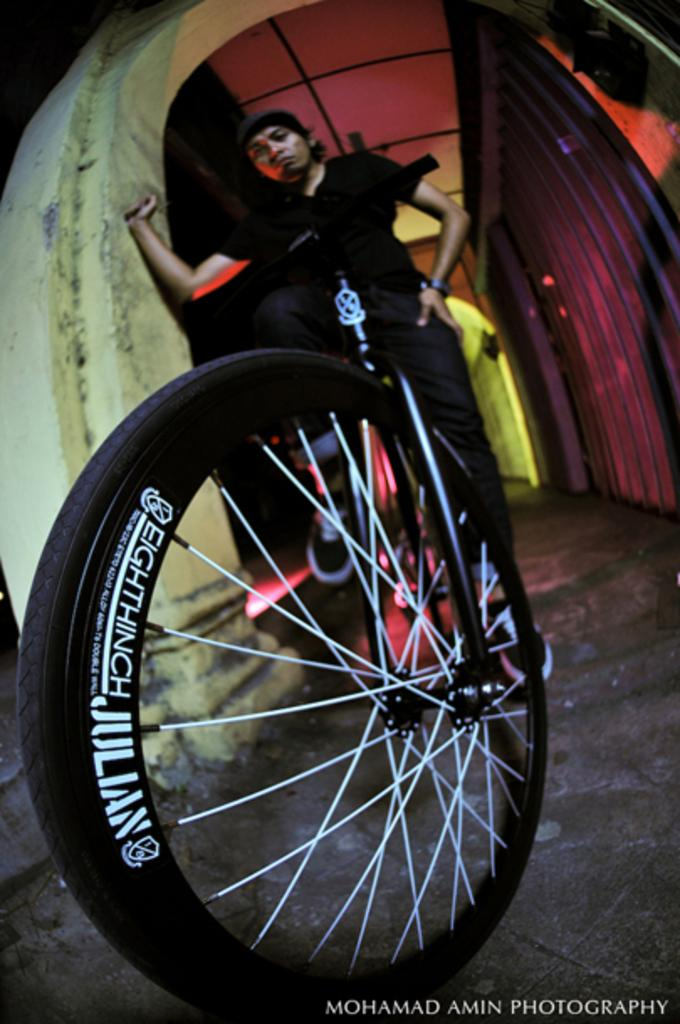What is the main subject of the image? There is a person on a bicycle in the image. What can be seen in the background of the image? There is a wall in the image. What part of the room or space is visible in the image? There is a ceiling visible in the image. Reasoning: Let's think step by step by step in order to produce the conversation. We start by identifying the main subject of the image, which is the person on a bicycle. Then, we describe the background and the surrounding environment, mentioning the wall and the ceiling. Each question is designed to elicit a specific detail about the image that is known from the provided facts. Absurd Question/Answer: What type of farm animals can be seen in the image? There are no farm animals present in the image; it features a person on a bicycle with a wall and a ceiling visible. 